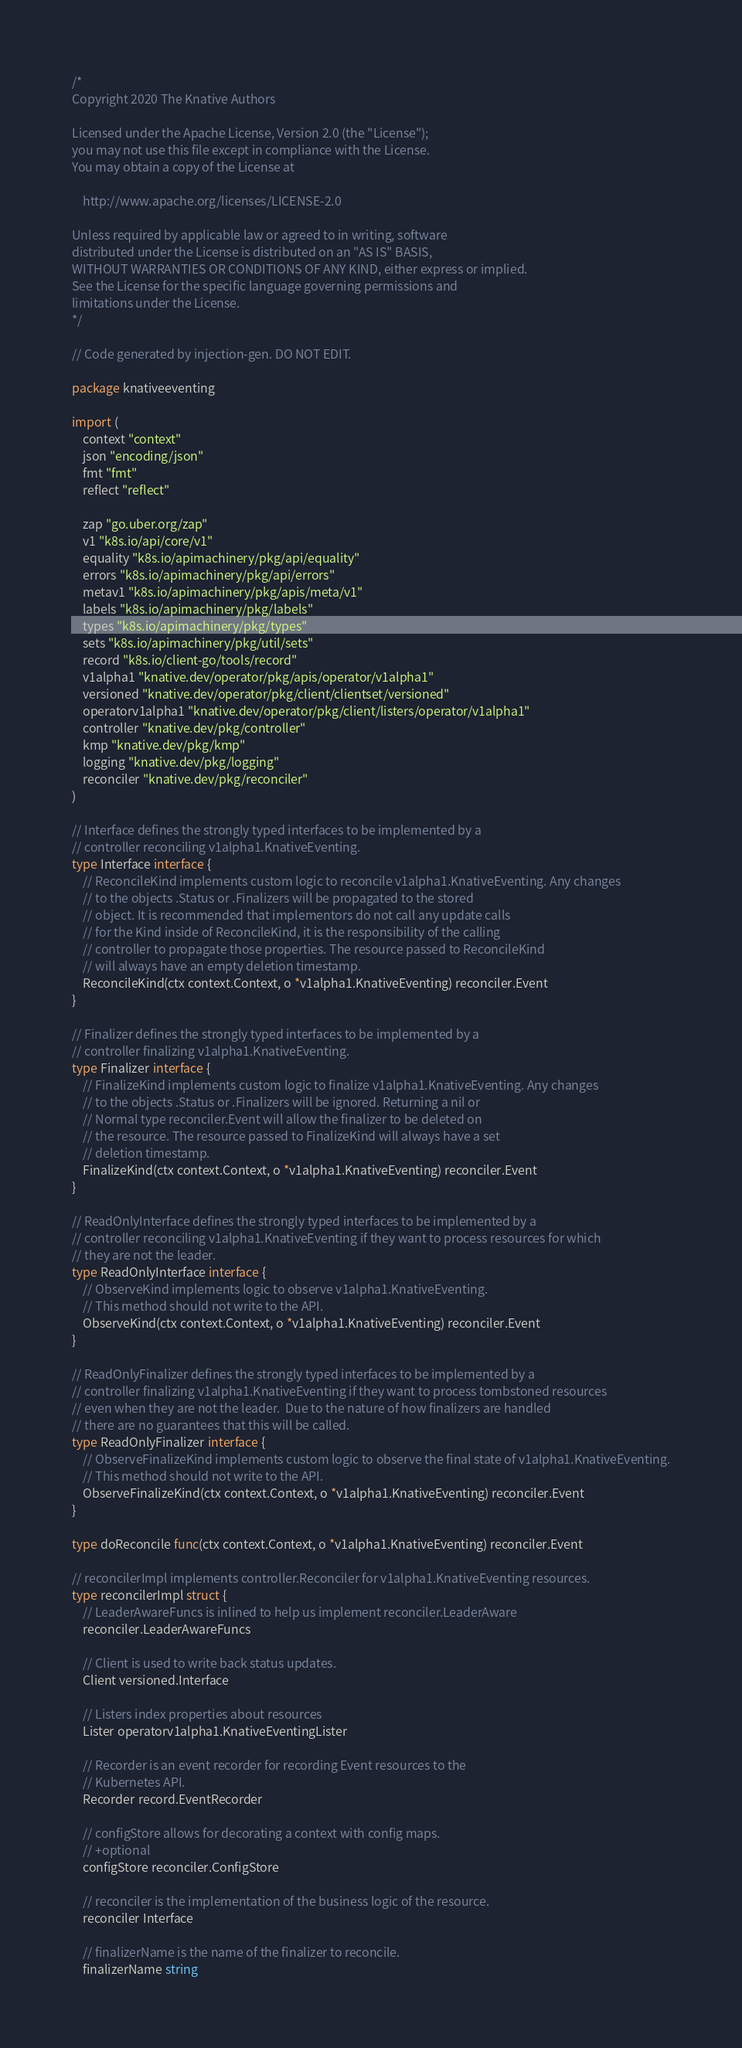<code> <loc_0><loc_0><loc_500><loc_500><_Go_>/*
Copyright 2020 The Knative Authors

Licensed under the Apache License, Version 2.0 (the "License");
you may not use this file except in compliance with the License.
You may obtain a copy of the License at

    http://www.apache.org/licenses/LICENSE-2.0

Unless required by applicable law or agreed to in writing, software
distributed under the License is distributed on an "AS IS" BASIS,
WITHOUT WARRANTIES OR CONDITIONS OF ANY KIND, either express or implied.
See the License for the specific language governing permissions and
limitations under the License.
*/

// Code generated by injection-gen. DO NOT EDIT.

package knativeeventing

import (
	context "context"
	json "encoding/json"
	fmt "fmt"
	reflect "reflect"

	zap "go.uber.org/zap"
	v1 "k8s.io/api/core/v1"
	equality "k8s.io/apimachinery/pkg/api/equality"
	errors "k8s.io/apimachinery/pkg/api/errors"
	metav1 "k8s.io/apimachinery/pkg/apis/meta/v1"
	labels "k8s.io/apimachinery/pkg/labels"
	types "k8s.io/apimachinery/pkg/types"
	sets "k8s.io/apimachinery/pkg/util/sets"
	record "k8s.io/client-go/tools/record"
	v1alpha1 "knative.dev/operator/pkg/apis/operator/v1alpha1"
	versioned "knative.dev/operator/pkg/client/clientset/versioned"
	operatorv1alpha1 "knative.dev/operator/pkg/client/listers/operator/v1alpha1"
	controller "knative.dev/pkg/controller"
	kmp "knative.dev/pkg/kmp"
	logging "knative.dev/pkg/logging"
	reconciler "knative.dev/pkg/reconciler"
)

// Interface defines the strongly typed interfaces to be implemented by a
// controller reconciling v1alpha1.KnativeEventing.
type Interface interface {
	// ReconcileKind implements custom logic to reconcile v1alpha1.KnativeEventing. Any changes
	// to the objects .Status or .Finalizers will be propagated to the stored
	// object. It is recommended that implementors do not call any update calls
	// for the Kind inside of ReconcileKind, it is the responsibility of the calling
	// controller to propagate those properties. The resource passed to ReconcileKind
	// will always have an empty deletion timestamp.
	ReconcileKind(ctx context.Context, o *v1alpha1.KnativeEventing) reconciler.Event
}

// Finalizer defines the strongly typed interfaces to be implemented by a
// controller finalizing v1alpha1.KnativeEventing.
type Finalizer interface {
	// FinalizeKind implements custom logic to finalize v1alpha1.KnativeEventing. Any changes
	// to the objects .Status or .Finalizers will be ignored. Returning a nil or
	// Normal type reconciler.Event will allow the finalizer to be deleted on
	// the resource. The resource passed to FinalizeKind will always have a set
	// deletion timestamp.
	FinalizeKind(ctx context.Context, o *v1alpha1.KnativeEventing) reconciler.Event
}

// ReadOnlyInterface defines the strongly typed interfaces to be implemented by a
// controller reconciling v1alpha1.KnativeEventing if they want to process resources for which
// they are not the leader.
type ReadOnlyInterface interface {
	// ObserveKind implements logic to observe v1alpha1.KnativeEventing.
	// This method should not write to the API.
	ObserveKind(ctx context.Context, o *v1alpha1.KnativeEventing) reconciler.Event
}

// ReadOnlyFinalizer defines the strongly typed interfaces to be implemented by a
// controller finalizing v1alpha1.KnativeEventing if they want to process tombstoned resources
// even when they are not the leader.  Due to the nature of how finalizers are handled
// there are no guarantees that this will be called.
type ReadOnlyFinalizer interface {
	// ObserveFinalizeKind implements custom logic to observe the final state of v1alpha1.KnativeEventing.
	// This method should not write to the API.
	ObserveFinalizeKind(ctx context.Context, o *v1alpha1.KnativeEventing) reconciler.Event
}

type doReconcile func(ctx context.Context, o *v1alpha1.KnativeEventing) reconciler.Event

// reconcilerImpl implements controller.Reconciler for v1alpha1.KnativeEventing resources.
type reconcilerImpl struct {
	// LeaderAwareFuncs is inlined to help us implement reconciler.LeaderAware
	reconciler.LeaderAwareFuncs

	// Client is used to write back status updates.
	Client versioned.Interface

	// Listers index properties about resources
	Lister operatorv1alpha1.KnativeEventingLister

	// Recorder is an event recorder for recording Event resources to the
	// Kubernetes API.
	Recorder record.EventRecorder

	// configStore allows for decorating a context with config maps.
	// +optional
	configStore reconciler.ConfigStore

	// reconciler is the implementation of the business logic of the resource.
	reconciler Interface

	// finalizerName is the name of the finalizer to reconcile.
	finalizerName string
</code> 